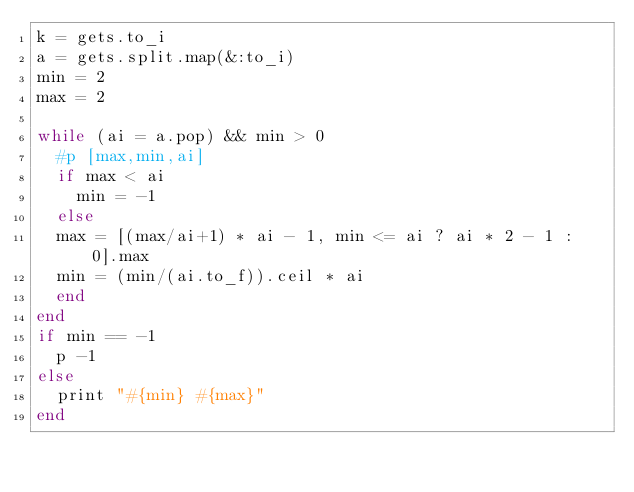<code> <loc_0><loc_0><loc_500><loc_500><_Ruby_>k = gets.to_i
a = gets.split.map(&:to_i)
min = 2
max = 2

while (ai = a.pop) && min > 0
  #p [max,min,ai]
  if max < ai
    min = -1
  else
  max = [(max/ai+1) * ai - 1, min <= ai ? ai * 2 - 1 : 0].max
  min = (min/(ai.to_f)).ceil * ai
  end
end
if min == -1
  p -1
else
  print "#{min} #{max}"
end
</code> 